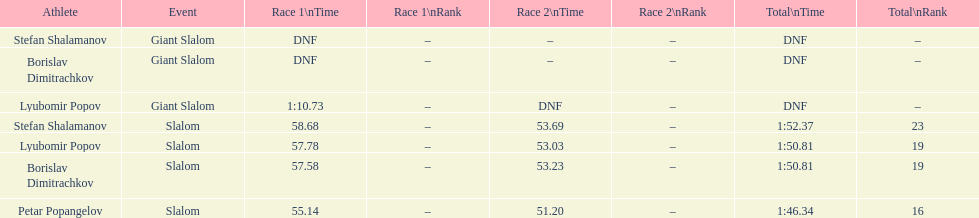Who has the highest rank? Petar Popangelov. 